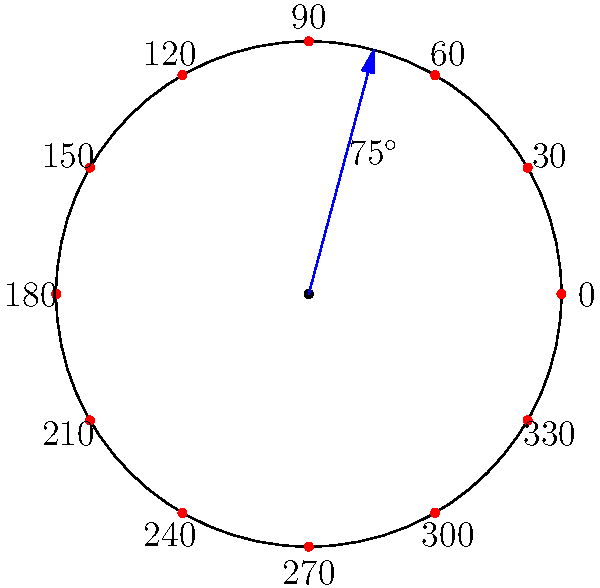In traditional Chinese medicine, acupuncture points are often mapped on a circular body diagram. Using the polar coordinate system shown, where the radius is 3 units and angles are measured counterclockwise from the positive x-axis, at which coordinates (r, θ) would you place an acupuncture point that lies 75° counterclockwise from the positive x-axis? To determine the polar coordinates of the acupuncture point, we need to consider:

1. The radius (r) of the circular diagram, which is given as 3 units.
2. The angle (θ) measured counterclockwise from the positive x-axis, which is specified as 75°.

In polar coordinates, a point is represented as (r, θ), where:
- r is the distance from the origin to the point
- θ is the angle from the positive x-axis (usually in radians, but degrees are also used)

In this case:
- r = 3 (the radius of the circular diagram)
- θ = 75° (the angle given in the question)

Therefore, the polar coordinates of the acupuncture point are (3, 75°).

Note: In some cases, you might need to convert the angle to radians. The conversion would be:
$$75° \times \frac{\pi}{180°} = \frac{5\pi}{12} \approx 1.309 \text{ radians}$$

However, for this question, we can leave the angle in degrees as it's commonly used in practical applications.
Answer: (3, 75°) 